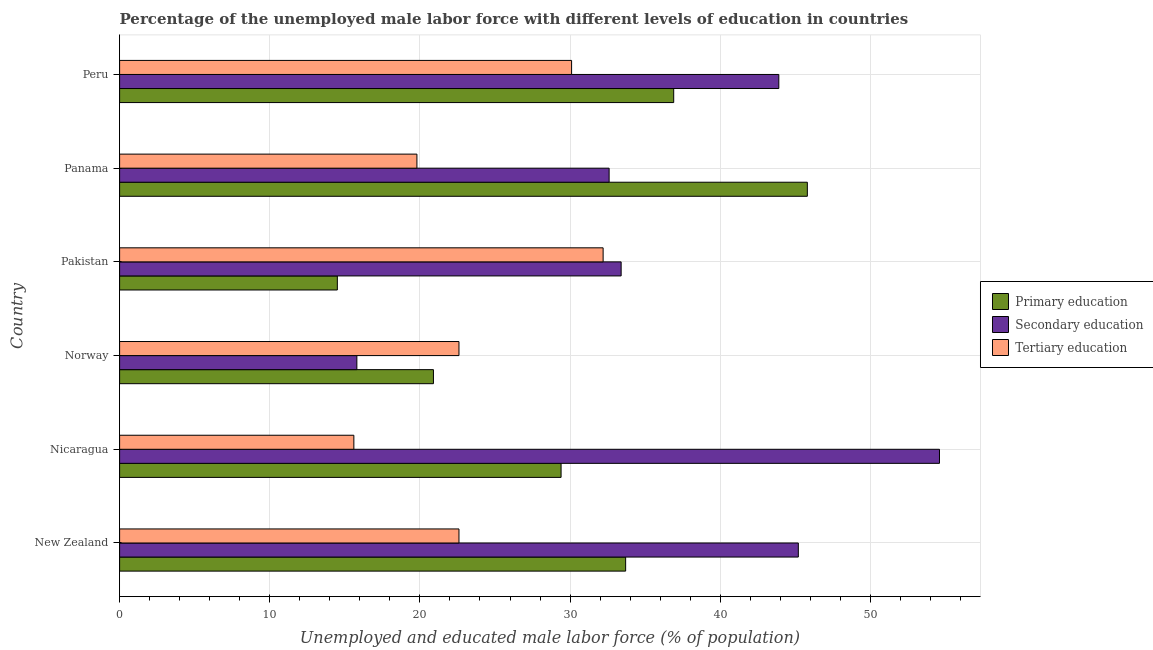How many groups of bars are there?
Give a very brief answer. 6. Are the number of bars on each tick of the Y-axis equal?
Offer a very short reply. Yes. What is the label of the 5th group of bars from the top?
Your response must be concise. Nicaragua. What is the percentage of male labor force who received tertiary education in Panama?
Your answer should be very brief. 19.8. Across all countries, what is the maximum percentage of male labor force who received tertiary education?
Offer a terse response. 32.2. Across all countries, what is the minimum percentage of male labor force who received secondary education?
Make the answer very short. 15.8. What is the total percentage of male labor force who received primary education in the graph?
Provide a succinct answer. 181.2. What is the difference between the percentage of male labor force who received secondary education in Pakistan and that in Panama?
Give a very brief answer. 0.8. What is the difference between the percentage of male labor force who received primary education in Panama and the percentage of male labor force who received tertiary education in New Zealand?
Your answer should be compact. 23.2. What is the average percentage of male labor force who received secondary education per country?
Ensure brevity in your answer.  37.58. What is the difference between the percentage of male labor force who received primary education and percentage of male labor force who received tertiary education in Norway?
Your response must be concise. -1.7. In how many countries, is the percentage of male labor force who received primary education greater than 32 %?
Make the answer very short. 3. What is the ratio of the percentage of male labor force who received primary education in Norway to that in Peru?
Give a very brief answer. 0.57. Is the percentage of male labor force who received primary education in New Zealand less than that in Panama?
Make the answer very short. Yes. Is the difference between the percentage of male labor force who received secondary education in New Zealand and Peru greater than the difference between the percentage of male labor force who received primary education in New Zealand and Peru?
Keep it short and to the point. Yes. What is the difference between the highest and the second highest percentage of male labor force who received secondary education?
Ensure brevity in your answer.  9.4. What is the difference between the highest and the lowest percentage of male labor force who received primary education?
Your answer should be compact. 31.3. In how many countries, is the percentage of male labor force who received primary education greater than the average percentage of male labor force who received primary education taken over all countries?
Ensure brevity in your answer.  3. What does the 2nd bar from the top in Peru represents?
Keep it short and to the point. Secondary education. What does the 1st bar from the bottom in Peru represents?
Provide a succinct answer. Primary education. Is it the case that in every country, the sum of the percentage of male labor force who received primary education and percentage of male labor force who received secondary education is greater than the percentage of male labor force who received tertiary education?
Your answer should be very brief. Yes. What is the difference between two consecutive major ticks on the X-axis?
Offer a terse response. 10. Are the values on the major ticks of X-axis written in scientific E-notation?
Give a very brief answer. No. Does the graph contain any zero values?
Make the answer very short. No. Where does the legend appear in the graph?
Your answer should be compact. Center right. How are the legend labels stacked?
Offer a very short reply. Vertical. What is the title of the graph?
Make the answer very short. Percentage of the unemployed male labor force with different levels of education in countries. What is the label or title of the X-axis?
Your response must be concise. Unemployed and educated male labor force (% of population). What is the label or title of the Y-axis?
Offer a terse response. Country. What is the Unemployed and educated male labor force (% of population) in Primary education in New Zealand?
Your response must be concise. 33.7. What is the Unemployed and educated male labor force (% of population) in Secondary education in New Zealand?
Your response must be concise. 45.2. What is the Unemployed and educated male labor force (% of population) of Tertiary education in New Zealand?
Give a very brief answer. 22.6. What is the Unemployed and educated male labor force (% of population) of Primary education in Nicaragua?
Provide a short and direct response. 29.4. What is the Unemployed and educated male labor force (% of population) of Secondary education in Nicaragua?
Offer a very short reply. 54.6. What is the Unemployed and educated male labor force (% of population) in Tertiary education in Nicaragua?
Keep it short and to the point. 15.6. What is the Unemployed and educated male labor force (% of population) in Primary education in Norway?
Your response must be concise. 20.9. What is the Unemployed and educated male labor force (% of population) in Secondary education in Norway?
Your response must be concise. 15.8. What is the Unemployed and educated male labor force (% of population) in Tertiary education in Norway?
Make the answer very short. 22.6. What is the Unemployed and educated male labor force (% of population) in Primary education in Pakistan?
Provide a short and direct response. 14.5. What is the Unemployed and educated male labor force (% of population) of Secondary education in Pakistan?
Offer a terse response. 33.4. What is the Unemployed and educated male labor force (% of population) in Tertiary education in Pakistan?
Give a very brief answer. 32.2. What is the Unemployed and educated male labor force (% of population) of Primary education in Panama?
Keep it short and to the point. 45.8. What is the Unemployed and educated male labor force (% of population) in Secondary education in Panama?
Provide a short and direct response. 32.6. What is the Unemployed and educated male labor force (% of population) in Tertiary education in Panama?
Keep it short and to the point. 19.8. What is the Unemployed and educated male labor force (% of population) in Primary education in Peru?
Provide a short and direct response. 36.9. What is the Unemployed and educated male labor force (% of population) in Secondary education in Peru?
Ensure brevity in your answer.  43.9. What is the Unemployed and educated male labor force (% of population) in Tertiary education in Peru?
Provide a succinct answer. 30.1. Across all countries, what is the maximum Unemployed and educated male labor force (% of population) in Primary education?
Ensure brevity in your answer.  45.8. Across all countries, what is the maximum Unemployed and educated male labor force (% of population) in Secondary education?
Offer a very short reply. 54.6. Across all countries, what is the maximum Unemployed and educated male labor force (% of population) of Tertiary education?
Your answer should be very brief. 32.2. Across all countries, what is the minimum Unemployed and educated male labor force (% of population) of Secondary education?
Your answer should be very brief. 15.8. Across all countries, what is the minimum Unemployed and educated male labor force (% of population) of Tertiary education?
Offer a terse response. 15.6. What is the total Unemployed and educated male labor force (% of population) of Primary education in the graph?
Keep it short and to the point. 181.2. What is the total Unemployed and educated male labor force (% of population) of Secondary education in the graph?
Your answer should be very brief. 225.5. What is the total Unemployed and educated male labor force (% of population) of Tertiary education in the graph?
Offer a terse response. 142.9. What is the difference between the Unemployed and educated male labor force (% of population) in Secondary education in New Zealand and that in Nicaragua?
Offer a terse response. -9.4. What is the difference between the Unemployed and educated male labor force (% of population) in Secondary education in New Zealand and that in Norway?
Ensure brevity in your answer.  29.4. What is the difference between the Unemployed and educated male labor force (% of population) of Secondary education in New Zealand and that in Pakistan?
Offer a terse response. 11.8. What is the difference between the Unemployed and educated male labor force (% of population) of Primary education in New Zealand and that in Panama?
Offer a very short reply. -12.1. What is the difference between the Unemployed and educated male labor force (% of population) of Secondary education in New Zealand and that in Panama?
Provide a succinct answer. 12.6. What is the difference between the Unemployed and educated male labor force (% of population) of Tertiary education in New Zealand and that in Panama?
Offer a terse response. 2.8. What is the difference between the Unemployed and educated male labor force (% of population) of Primary education in New Zealand and that in Peru?
Your answer should be compact. -3.2. What is the difference between the Unemployed and educated male labor force (% of population) in Tertiary education in New Zealand and that in Peru?
Your answer should be compact. -7.5. What is the difference between the Unemployed and educated male labor force (% of population) of Primary education in Nicaragua and that in Norway?
Ensure brevity in your answer.  8.5. What is the difference between the Unemployed and educated male labor force (% of population) in Secondary education in Nicaragua and that in Norway?
Your response must be concise. 38.8. What is the difference between the Unemployed and educated male labor force (% of population) in Secondary education in Nicaragua and that in Pakistan?
Your answer should be very brief. 21.2. What is the difference between the Unemployed and educated male labor force (% of population) in Tertiary education in Nicaragua and that in Pakistan?
Ensure brevity in your answer.  -16.6. What is the difference between the Unemployed and educated male labor force (% of population) of Primary education in Nicaragua and that in Panama?
Offer a terse response. -16.4. What is the difference between the Unemployed and educated male labor force (% of population) of Secondary education in Nicaragua and that in Panama?
Provide a short and direct response. 22. What is the difference between the Unemployed and educated male labor force (% of population) of Tertiary education in Nicaragua and that in Panama?
Give a very brief answer. -4.2. What is the difference between the Unemployed and educated male labor force (% of population) of Secondary education in Norway and that in Pakistan?
Give a very brief answer. -17.6. What is the difference between the Unemployed and educated male labor force (% of population) of Tertiary education in Norway and that in Pakistan?
Make the answer very short. -9.6. What is the difference between the Unemployed and educated male labor force (% of population) in Primary education in Norway and that in Panama?
Offer a terse response. -24.9. What is the difference between the Unemployed and educated male labor force (% of population) of Secondary education in Norway and that in Panama?
Make the answer very short. -16.8. What is the difference between the Unemployed and educated male labor force (% of population) of Tertiary education in Norway and that in Panama?
Give a very brief answer. 2.8. What is the difference between the Unemployed and educated male labor force (% of population) of Primary education in Norway and that in Peru?
Your answer should be compact. -16. What is the difference between the Unemployed and educated male labor force (% of population) of Secondary education in Norway and that in Peru?
Provide a succinct answer. -28.1. What is the difference between the Unemployed and educated male labor force (% of population) in Primary education in Pakistan and that in Panama?
Provide a short and direct response. -31.3. What is the difference between the Unemployed and educated male labor force (% of population) in Primary education in Pakistan and that in Peru?
Ensure brevity in your answer.  -22.4. What is the difference between the Unemployed and educated male labor force (% of population) of Secondary education in Pakistan and that in Peru?
Offer a terse response. -10.5. What is the difference between the Unemployed and educated male labor force (% of population) in Tertiary education in Pakistan and that in Peru?
Provide a succinct answer. 2.1. What is the difference between the Unemployed and educated male labor force (% of population) of Primary education in Panama and that in Peru?
Give a very brief answer. 8.9. What is the difference between the Unemployed and educated male labor force (% of population) of Secondary education in Panama and that in Peru?
Keep it short and to the point. -11.3. What is the difference between the Unemployed and educated male labor force (% of population) in Primary education in New Zealand and the Unemployed and educated male labor force (% of population) in Secondary education in Nicaragua?
Provide a short and direct response. -20.9. What is the difference between the Unemployed and educated male labor force (% of population) of Secondary education in New Zealand and the Unemployed and educated male labor force (% of population) of Tertiary education in Nicaragua?
Your response must be concise. 29.6. What is the difference between the Unemployed and educated male labor force (% of population) of Primary education in New Zealand and the Unemployed and educated male labor force (% of population) of Secondary education in Norway?
Offer a very short reply. 17.9. What is the difference between the Unemployed and educated male labor force (% of population) in Secondary education in New Zealand and the Unemployed and educated male labor force (% of population) in Tertiary education in Norway?
Give a very brief answer. 22.6. What is the difference between the Unemployed and educated male labor force (% of population) of Primary education in New Zealand and the Unemployed and educated male labor force (% of population) of Secondary education in Pakistan?
Ensure brevity in your answer.  0.3. What is the difference between the Unemployed and educated male labor force (% of population) in Primary education in New Zealand and the Unemployed and educated male labor force (% of population) in Tertiary education in Pakistan?
Ensure brevity in your answer.  1.5. What is the difference between the Unemployed and educated male labor force (% of population) in Secondary education in New Zealand and the Unemployed and educated male labor force (% of population) in Tertiary education in Pakistan?
Offer a terse response. 13. What is the difference between the Unemployed and educated male labor force (% of population) of Primary education in New Zealand and the Unemployed and educated male labor force (% of population) of Tertiary education in Panama?
Provide a short and direct response. 13.9. What is the difference between the Unemployed and educated male labor force (% of population) of Secondary education in New Zealand and the Unemployed and educated male labor force (% of population) of Tertiary education in Panama?
Your response must be concise. 25.4. What is the difference between the Unemployed and educated male labor force (% of population) of Secondary education in New Zealand and the Unemployed and educated male labor force (% of population) of Tertiary education in Peru?
Your response must be concise. 15.1. What is the difference between the Unemployed and educated male labor force (% of population) of Primary education in Nicaragua and the Unemployed and educated male labor force (% of population) of Tertiary education in Norway?
Offer a terse response. 6.8. What is the difference between the Unemployed and educated male labor force (% of population) of Secondary education in Nicaragua and the Unemployed and educated male labor force (% of population) of Tertiary education in Pakistan?
Keep it short and to the point. 22.4. What is the difference between the Unemployed and educated male labor force (% of population) in Secondary education in Nicaragua and the Unemployed and educated male labor force (% of population) in Tertiary education in Panama?
Provide a succinct answer. 34.8. What is the difference between the Unemployed and educated male labor force (% of population) in Secondary education in Nicaragua and the Unemployed and educated male labor force (% of population) in Tertiary education in Peru?
Provide a succinct answer. 24.5. What is the difference between the Unemployed and educated male labor force (% of population) in Secondary education in Norway and the Unemployed and educated male labor force (% of population) in Tertiary education in Pakistan?
Give a very brief answer. -16.4. What is the difference between the Unemployed and educated male labor force (% of population) in Primary education in Norway and the Unemployed and educated male labor force (% of population) in Secondary education in Panama?
Provide a short and direct response. -11.7. What is the difference between the Unemployed and educated male labor force (% of population) in Secondary education in Norway and the Unemployed and educated male labor force (% of population) in Tertiary education in Panama?
Give a very brief answer. -4. What is the difference between the Unemployed and educated male labor force (% of population) of Primary education in Norway and the Unemployed and educated male labor force (% of population) of Secondary education in Peru?
Keep it short and to the point. -23. What is the difference between the Unemployed and educated male labor force (% of population) of Secondary education in Norway and the Unemployed and educated male labor force (% of population) of Tertiary education in Peru?
Keep it short and to the point. -14.3. What is the difference between the Unemployed and educated male labor force (% of population) of Primary education in Pakistan and the Unemployed and educated male labor force (% of population) of Secondary education in Panama?
Provide a short and direct response. -18.1. What is the difference between the Unemployed and educated male labor force (% of population) of Primary education in Pakistan and the Unemployed and educated male labor force (% of population) of Secondary education in Peru?
Keep it short and to the point. -29.4. What is the difference between the Unemployed and educated male labor force (% of population) of Primary education in Pakistan and the Unemployed and educated male labor force (% of population) of Tertiary education in Peru?
Offer a terse response. -15.6. What is the difference between the Unemployed and educated male labor force (% of population) of Secondary education in Panama and the Unemployed and educated male labor force (% of population) of Tertiary education in Peru?
Your answer should be compact. 2.5. What is the average Unemployed and educated male labor force (% of population) of Primary education per country?
Provide a succinct answer. 30.2. What is the average Unemployed and educated male labor force (% of population) in Secondary education per country?
Make the answer very short. 37.58. What is the average Unemployed and educated male labor force (% of population) in Tertiary education per country?
Your answer should be compact. 23.82. What is the difference between the Unemployed and educated male labor force (% of population) in Primary education and Unemployed and educated male labor force (% of population) in Secondary education in New Zealand?
Make the answer very short. -11.5. What is the difference between the Unemployed and educated male labor force (% of population) of Secondary education and Unemployed and educated male labor force (% of population) of Tertiary education in New Zealand?
Keep it short and to the point. 22.6. What is the difference between the Unemployed and educated male labor force (% of population) in Primary education and Unemployed and educated male labor force (% of population) in Secondary education in Nicaragua?
Give a very brief answer. -25.2. What is the difference between the Unemployed and educated male labor force (% of population) in Primary education and Unemployed and educated male labor force (% of population) in Secondary education in Norway?
Offer a terse response. 5.1. What is the difference between the Unemployed and educated male labor force (% of population) in Primary education and Unemployed and educated male labor force (% of population) in Tertiary education in Norway?
Your response must be concise. -1.7. What is the difference between the Unemployed and educated male labor force (% of population) in Secondary education and Unemployed and educated male labor force (% of population) in Tertiary education in Norway?
Your answer should be very brief. -6.8. What is the difference between the Unemployed and educated male labor force (% of population) in Primary education and Unemployed and educated male labor force (% of population) in Secondary education in Pakistan?
Make the answer very short. -18.9. What is the difference between the Unemployed and educated male labor force (% of population) of Primary education and Unemployed and educated male labor force (% of population) of Tertiary education in Pakistan?
Provide a short and direct response. -17.7. What is the difference between the Unemployed and educated male labor force (% of population) of Primary education and Unemployed and educated male labor force (% of population) of Secondary education in Panama?
Your response must be concise. 13.2. What is the difference between the Unemployed and educated male labor force (% of population) of Primary education and Unemployed and educated male labor force (% of population) of Tertiary education in Panama?
Your response must be concise. 26. What is the difference between the Unemployed and educated male labor force (% of population) in Secondary education and Unemployed and educated male labor force (% of population) in Tertiary education in Panama?
Make the answer very short. 12.8. What is the difference between the Unemployed and educated male labor force (% of population) in Primary education and Unemployed and educated male labor force (% of population) in Secondary education in Peru?
Give a very brief answer. -7. What is the difference between the Unemployed and educated male labor force (% of population) of Primary education and Unemployed and educated male labor force (% of population) of Tertiary education in Peru?
Offer a very short reply. 6.8. What is the ratio of the Unemployed and educated male labor force (% of population) in Primary education in New Zealand to that in Nicaragua?
Give a very brief answer. 1.15. What is the ratio of the Unemployed and educated male labor force (% of population) of Secondary education in New Zealand to that in Nicaragua?
Your answer should be compact. 0.83. What is the ratio of the Unemployed and educated male labor force (% of population) in Tertiary education in New Zealand to that in Nicaragua?
Your response must be concise. 1.45. What is the ratio of the Unemployed and educated male labor force (% of population) of Primary education in New Zealand to that in Norway?
Give a very brief answer. 1.61. What is the ratio of the Unemployed and educated male labor force (% of population) in Secondary education in New Zealand to that in Norway?
Your answer should be very brief. 2.86. What is the ratio of the Unemployed and educated male labor force (% of population) in Primary education in New Zealand to that in Pakistan?
Offer a very short reply. 2.32. What is the ratio of the Unemployed and educated male labor force (% of population) of Secondary education in New Zealand to that in Pakistan?
Give a very brief answer. 1.35. What is the ratio of the Unemployed and educated male labor force (% of population) in Tertiary education in New Zealand to that in Pakistan?
Give a very brief answer. 0.7. What is the ratio of the Unemployed and educated male labor force (% of population) in Primary education in New Zealand to that in Panama?
Provide a succinct answer. 0.74. What is the ratio of the Unemployed and educated male labor force (% of population) in Secondary education in New Zealand to that in Panama?
Make the answer very short. 1.39. What is the ratio of the Unemployed and educated male labor force (% of population) in Tertiary education in New Zealand to that in Panama?
Your response must be concise. 1.14. What is the ratio of the Unemployed and educated male labor force (% of population) in Primary education in New Zealand to that in Peru?
Your answer should be compact. 0.91. What is the ratio of the Unemployed and educated male labor force (% of population) of Secondary education in New Zealand to that in Peru?
Your answer should be very brief. 1.03. What is the ratio of the Unemployed and educated male labor force (% of population) in Tertiary education in New Zealand to that in Peru?
Provide a succinct answer. 0.75. What is the ratio of the Unemployed and educated male labor force (% of population) of Primary education in Nicaragua to that in Norway?
Make the answer very short. 1.41. What is the ratio of the Unemployed and educated male labor force (% of population) in Secondary education in Nicaragua to that in Norway?
Offer a very short reply. 3.46. What is the ratio of the Unemployed and educated male labor force (% of population) of Tertiary education in Nicaragua to that in Norway?
Your answer should be very brief. 0.69. What is the ratio of the Unemployed and educated male labor force (% of population) of Primary education in Nicaragua to that in Pakistan?
Your answer should be compact. 2.03. What is the ratio of the Unemployed and educated male labor force (% of population) in Secondary education in Nicaragua to that in Pakistan?
Provide a short and direct response. 1.63. What is the ratio of the Unemployed and educated male labor force (% of population) of Tertiary education in Nicaragua to that in Pakistan?
Give a very brief answer. 0.48. What is the ratio of the Unemployed and educated male labor force (% of population) of Primary education in Nicaragua to that in Panama?
Your response must be concise. 0.64. What is the ratio of the Unemployed and educated male labor force (% of population) of Secondary education in Nicaragua to that in Panama?
Keep it short and to the point. 1.67. What is the ratio of the Unemployed and educated male labor force (% of population) of Tertiary education in Nicaragua to that in Panama?
Your answer should be compact. 0.79. What is the ratio of the Unemployed and educated male labor force (% of population) in Primary education in Nicaragua to that in Peru?
Ensure brevity in your answer.  0.8. What is the ratio of the Unemployed and educated male labor force (% of population) of Secondary education in Nicaragua to that in Peru?
Give a very brief answer. 1.24. What is the ratio of the Unemployed and educated male labor force (% of population) of Tertiary education in Nicaragua to that in Peru?
Your response must be concise. 0.52. What is the ratio of the Unemployed and educated male labor force (% of population) of Primary education in Norway to that in Pakistan?
Provide a short and direct response. 1.44. What is the ratio of the Unemployed and educated male labor force (% of population) of Secondary education in Norway to that in Pakistan?
Offer a very short reply. 0.47. What is the ratio of the Unemployed and educated male labor force (% of population) in Tertiary education in Norway to that in Pakistan?
Your answer should be compact. 0.7. What is the ratio of the Unemployed and educated male labor force (% of population) in Primary education in Norway to that in Panama?
Provide a short and direct response. 0.46. What is the ratio of the Unemployed and educated male labor force (% of population) in Secondary education in Norway to that in Panama?
Your answer should be compact. 0.48. What is the ratio of the Unemployed and educated male labor force (% of population) of Tertiary education in Norway to that in Panama?
Give a very brief answer. 1.14. What is the ratio of the Unemployed and educated male labor force (% of population) in Primary education in Norway to that in Peru?
Make the answer very short. 0.57. What is the ratio of the Unemployed and educated male labor force (% of population) of Secondary education in Norway to that in Peru?
Ensure brevity in your answer.  0.36. What is the ratio of the Unemployed and educated male labor force (% of population) in Tertiary education in Norway to that in Peru?
Offer a terse response. 0.75. What is the ratio of the Unemployed and educated male labor force (% of population) in Primary education in Pakistan to that in Panama?
Keep it short and to the point. 0.32. What is the ratio of the Unemployed and educated male labor force (% of population) in Secondary education in Pakistan to that in Panama?
Make the answer very short. 1.02. What is the ratio of the Unemployed and educated male labor force (% of population) in Tertiary education in Pakistan to that in Panama?
Your answer should be very brief. 1.63. What is the ratio of the Unemployed and educated male labor force (% of population) of Primary education in Pakistan to that in Peru?
Give a very brief answer. 0.39. What is the ratio of the Unemployed and educated male labor force (% of population) in Secondary education in Pakistan to that in Peru?
Your answer should be compact. 0.76. What is the ratio of the Unemployed and educated male labor force (% of population) of Tertiary education in Pakistan to that in Peru?
Keep it short and to the point. 1.07. What is the ratio of the Unemployed and educated male labor force (% of population) of Primary education in Panama to that in Peru?
Your answer should be very brief. 1.24. What is the ratio of the Unemployed and educated male labor force (% of population) in Secondary education in Panama to that in Peru?
Give a very brief answer. 0.74. What is the ratio of the Unemployed and educated male labor force (% of population) of Tertiary education in Panama to that in Peru?
Offer a terse response. 0.66. What is the difference between the highest and the second highest Unemployed and educated male labor force (% of population) of Primary education?
Your response must be concise. 8.9. What is the difference between the highest and the second highest Unemployed and educated male labor force (% of population) in Tertiary education?
Provide a short and direct response. 2.1. What is the difference between the highest and the lowest Unemployed and educated male labor force (% of population) of Primary education?
Offer a very short reply. 31.3. What is the difference between the highest and the lowest Unemployed and educated male labor force (% of population) in Secondary education?
Provide a short and direct response. 38.8. What is the difference between the highest and the lowest Unemployed and educated male labor force (% of population) of Tertiary education?
Give a very brief answer. 16.6. 